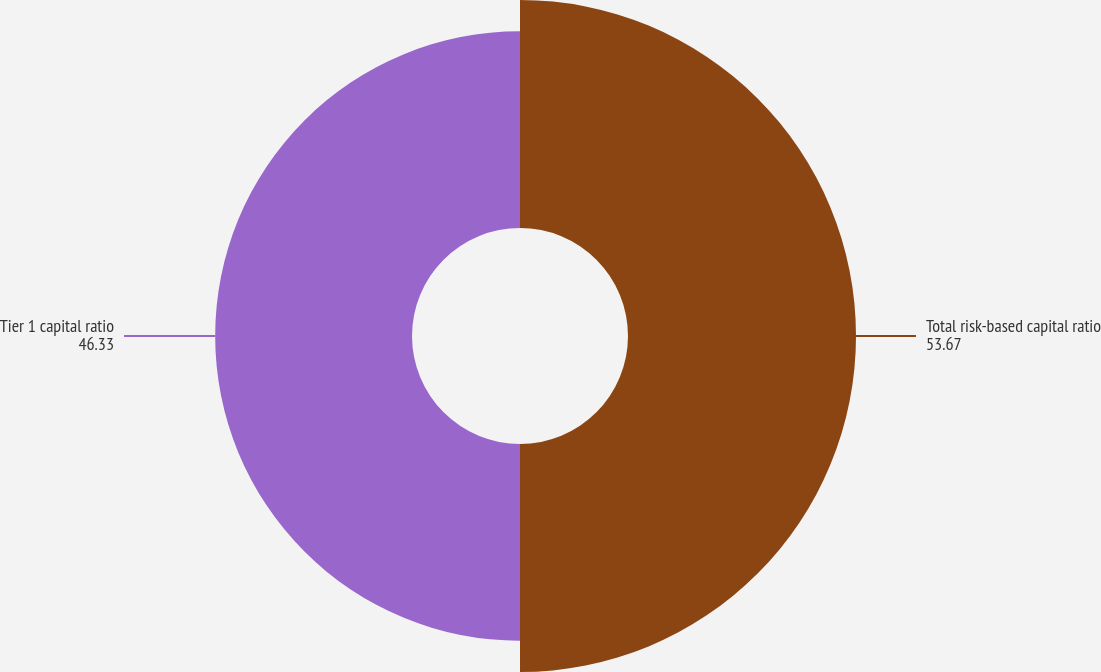<chart> <loc_0><loc_0><loc_500><loc_500><pie_chart><fcel>Total risk-based capital ratio<fcel>Tier 1 capital ratio<nl><fcel>53.67%<fcel>46.33%<nl></chart> 